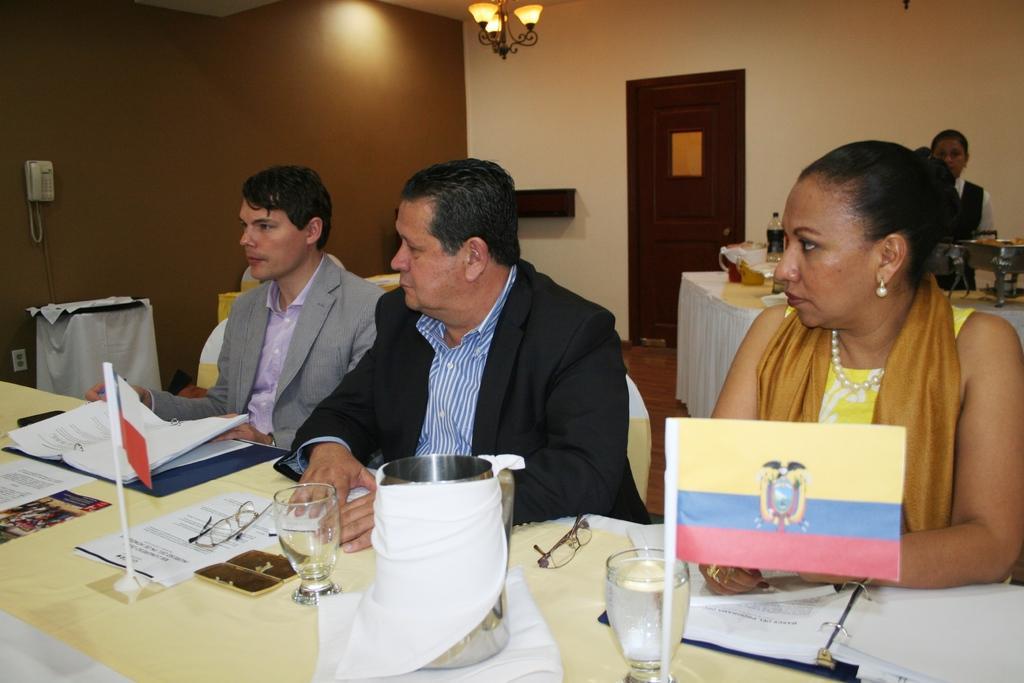Please provide a concise description of this image. In this picture there is a man who is wearing a grey suit who is sitting on the chair. There is also another man who is wearing a blue shirt and a black suit is also sitting on the chair. To the right,there is also a woman who is wearing a yellow dress. There is a glass on the table and a jug is also on the table. There is a spectacle and book is also on the table. There is a telephone attached to the wall. There is a light to the roof. At the background, there is a woman who is wearing a black suit and there is a food in the dish. There is a bottle on the table. There is a door which is brown in color. 